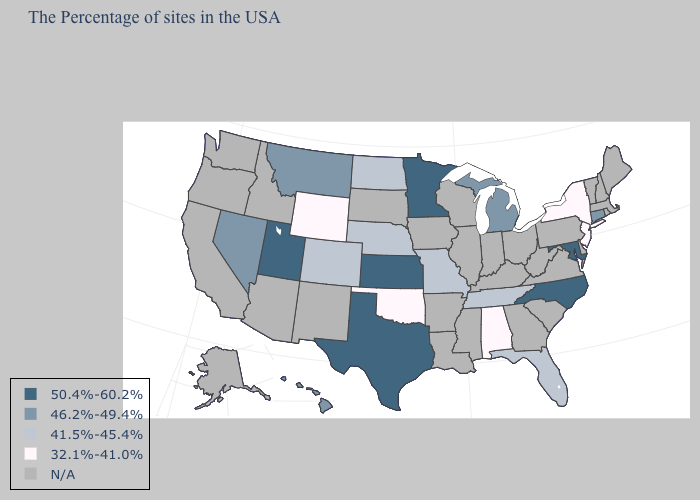Name the states that have a value in the range N/A?
Answer briefly. Maine, Massachusetts, Rhode Island, New Hampshire, Vermont, Delaware, Pennsylvania, Virginia, South Carolina, West Virginia, Ohio, Georgia, Kentucky, Indiana, Wisconsin, Illinois, Mississippi, Louisiana, Arkansas, Iowa, South Dakota, New Mexico, Arizona, Idaho, California, Washington, Oregon, Alaska. Name the states that have a value in the range N/A?
Answer briefly. Maine, Massachusetts, Rhode Island, New Hampshire, Vermont, Delaware, Pennsylvania, Virginia, South Carolina, West Virginia, Ohio, Georgia, Kentucky, Indiana, Wisconsin, Illinois, Mississippi, Louisiana, Arkansas, Iowa, South Dakota, New Mexico, Arizona, Idaho, California, Washington, Oregon, Alaska. Among the states that border West Virginia , which have the highest value?
Keep it brief. Maryland. Does Montana have the lowest value in the West?
Keep it brief. No. What is the lowest value in the West?
Quick response, please. 32.1%-41.0%. Does Colorado have the lowest value in the USA?
Concise answer only. No. Among the states that border Idaho , does Nevada have the highest value?
Write a very short answer. No. What is the value of Minnesota?
Give a very brief answer. 50.4%-60.2%. Name the states that have a value in the range 41.5%-45.4%?
Short answer required. Florida, Tennessee, Missouri, Nebraska, North Dakota, Colorado. What is the value of Michigan?
Keep it brief. 46.2%-49.4%. Name the states that have a value in the range 50.4%-60.2%?
Short answer required. Maryland, North Carolina, Minnesota, Kansas, Texas, Utah. Name the states that have a value in the range N/A?
Quick response, please. Maine, Massachusetts, Rhode Island, New Hampshire, Vermont, Delaware, Pennsylvania, Virginia, South Carolina, West Virginia, Ohio, Georgia, Kentucky, Indiana, Wisconsin, Illinois, Mississippi, Louisiana, Arkansas, Iowa, South Dakota, New Mexico, Arizona, Idaho, California, Washington, Oregon, Alaska. Among the states that border California , which have the highest value?
Quick response, please. Nevada. Which states have the lowest value in the USA?
Give a very brief answer. New York, New Jersey, Alabama, Oklahoma, Wyoming. 